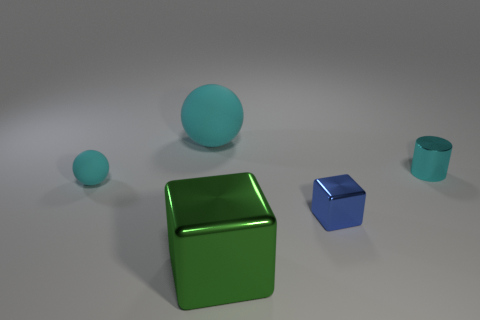Add 3 tiny yellow metal spheres. How many objects exist? 8 Subtract all cylinders. How many objects are left? 4 Subtract all cyan cylinders. Subtract all cyan cylinders. How many objects are left? 3 Add 4 tiny rubber spheres. How many tiny rubber spheres are left? 5 Add 1 blue metal cubes. How many blue metal cubes exist? 2 Subtract 0 red cubes. How many objects are left? 5 